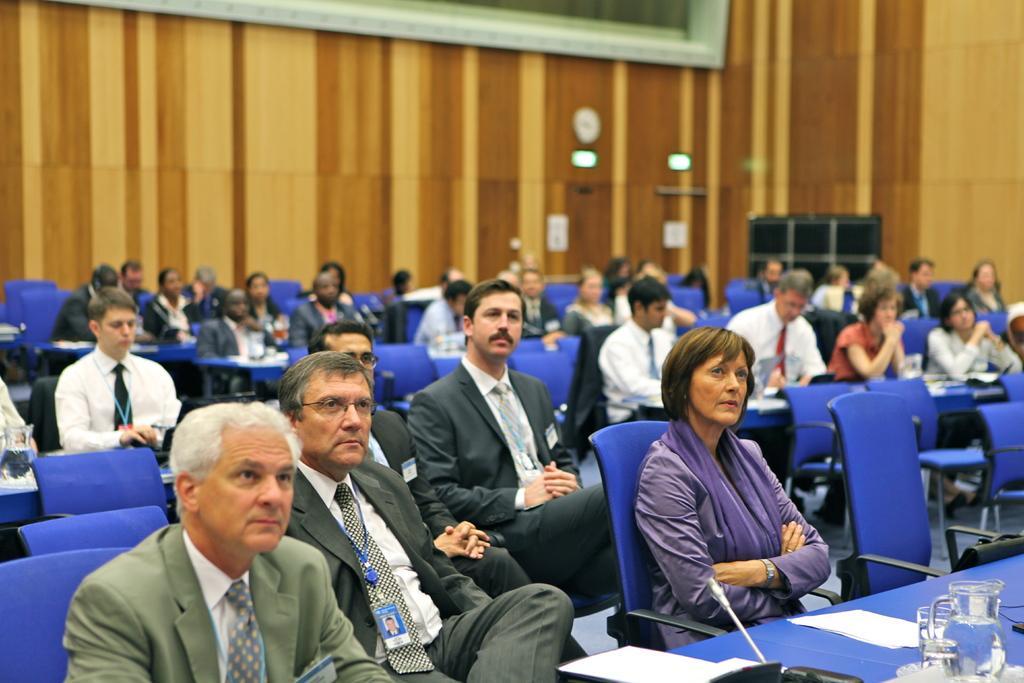Describe this image in one or two sentences. In this image, we can see people sitting on chairs and on bottom right, there is a jar and glass,papers on the table and in the background, there is wall. 